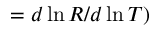Convert formula to latex. <formula><loc_0><loc_0><loc_500><loc_500>= d \ln { R } / d \ln { T } )</formula> 